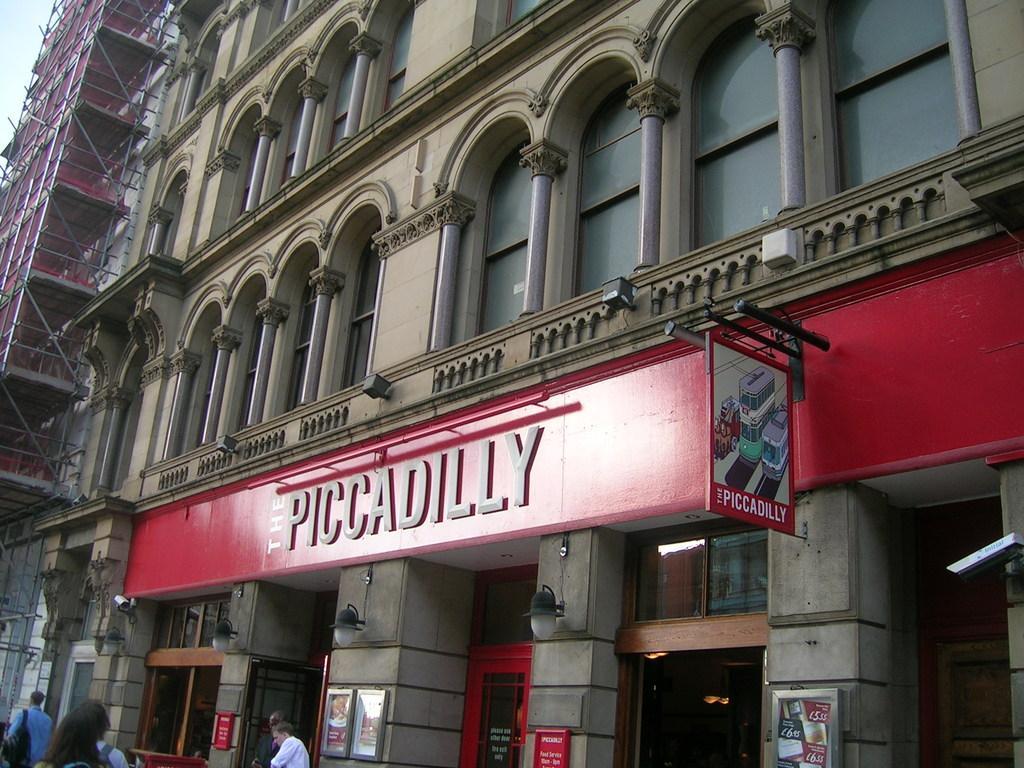Describe this image in one or two sentences. At the bottom on the left side we can see few persons and among them few are carrying bags on the shoulders and we can see buildings, poles, name boards, frames, lights and security camera on the wall, glass doors, other objects and sky. 